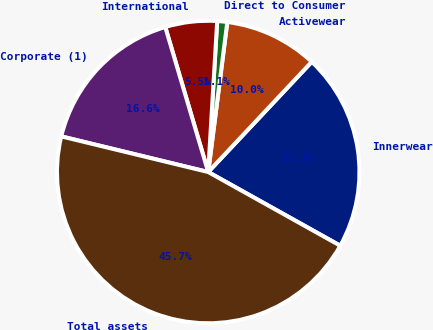<chart> <loc_0><loc_0><loc_500><loc_500><pie_chart><fcel>Innerwear<fcel>Activewear<fcel>Direct to Consumer<fcel>International<fcel>Corporate (1)<fcel>Total assets<nl><fcel>21.1%<fcel>9.99%<fcel>1.07%<fcel>5.53%<fcel>16.63%<fcel>45.69%<nl></chart> 